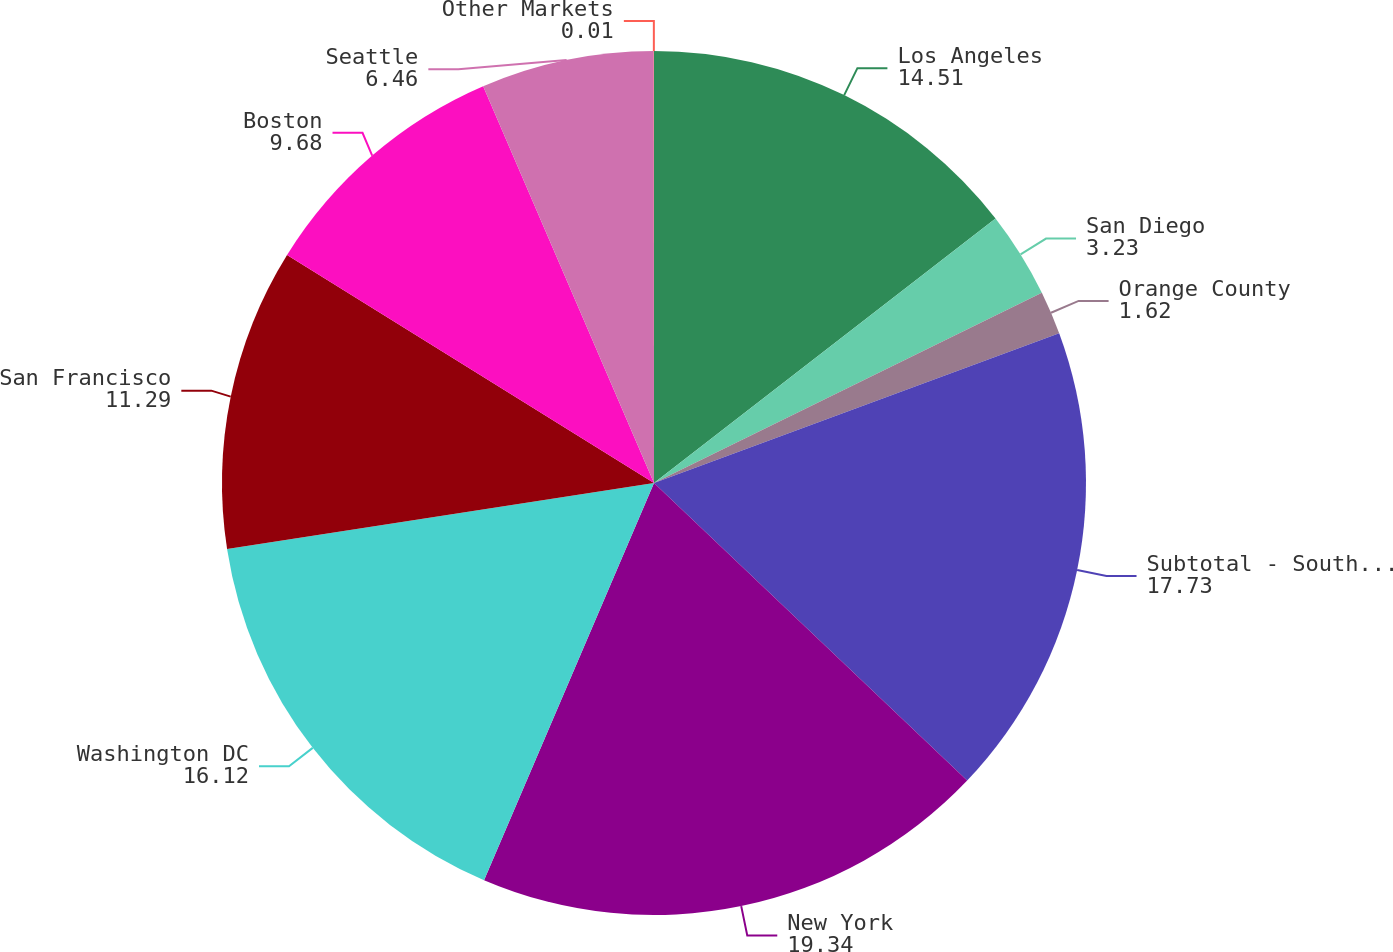<chart> <loc_0><loc_0><loc_500><loc_500><pie_chart><fcel>Los Angeles<fcel>San Diego<fcel>Orange County<fcel>Subtotal - Southern California<fcel>New York<fcel>Washington DC<fcel>San Francisco<fcel>Boston<fcel>Seattle<fcel>Other Markets<nl><fcel>14.51%<fcel>3.23%<fcel>1.62%<fcel>17.73%<fcel>19.34%<fcel>16.12%<fcel>11.29%<fcel>9.68%<fcel>6.46%<fcel>0.01%<nl></chart> 